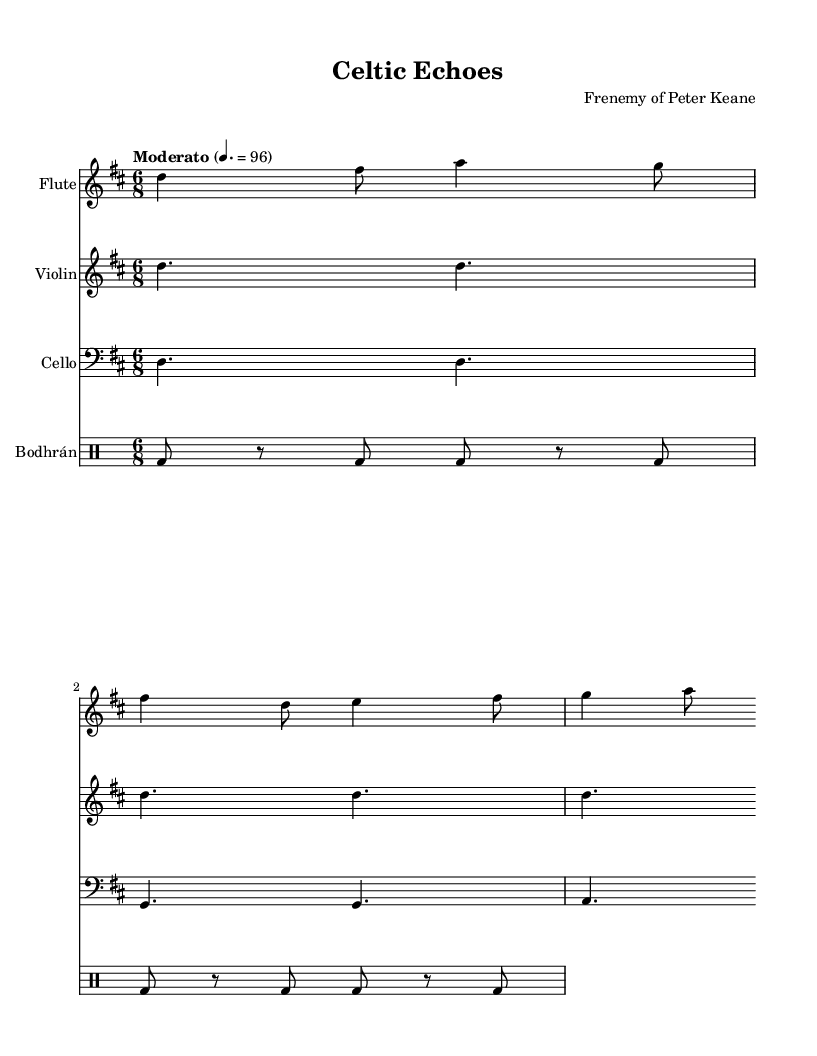What is the key signature of this music? The key signature is D major, which has two sharps: F# and C#.
Answer: D major What is the time signature of this music? The time signature is 6/8, indicating six eighth notes per measure.
Answer: 6/8 What is the tempo marking indicated in the music? The tempo marking is "Moderato," which generally means a moderate pace, and is specifically notated as 4 beats per minute equal to 96.
Answer: Moderato How many instruments are represented in the score? The score has four distinct instruments: Flute, Violin, Cello, and Bodhrán.
Answer: Four What rhythmic pattern does the Bodhrán play? The Bodhrán plays a pattern primarily made up of bass notes paired with rests, alternating between hitting and resting in an eighth note duration.
Answer: Bass and rests Which instrument has the longest sustained note in the first section of music? The Violin part features the longest sustained notes with a dotted half note value in the first section.
Answer: Violin What is the range of the cello's part in this section? The cello's part ranges from D in the bass clef, moving to G and A, which indicates a lower pitch range compared to the flute and violin.
Answer: D to A 